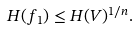<formula> <loc_0><loc_0><loc_500><loc_500>H ( f _ { 1 } ) \leq H ( V ) ^ { 1 / n } .</formula> 